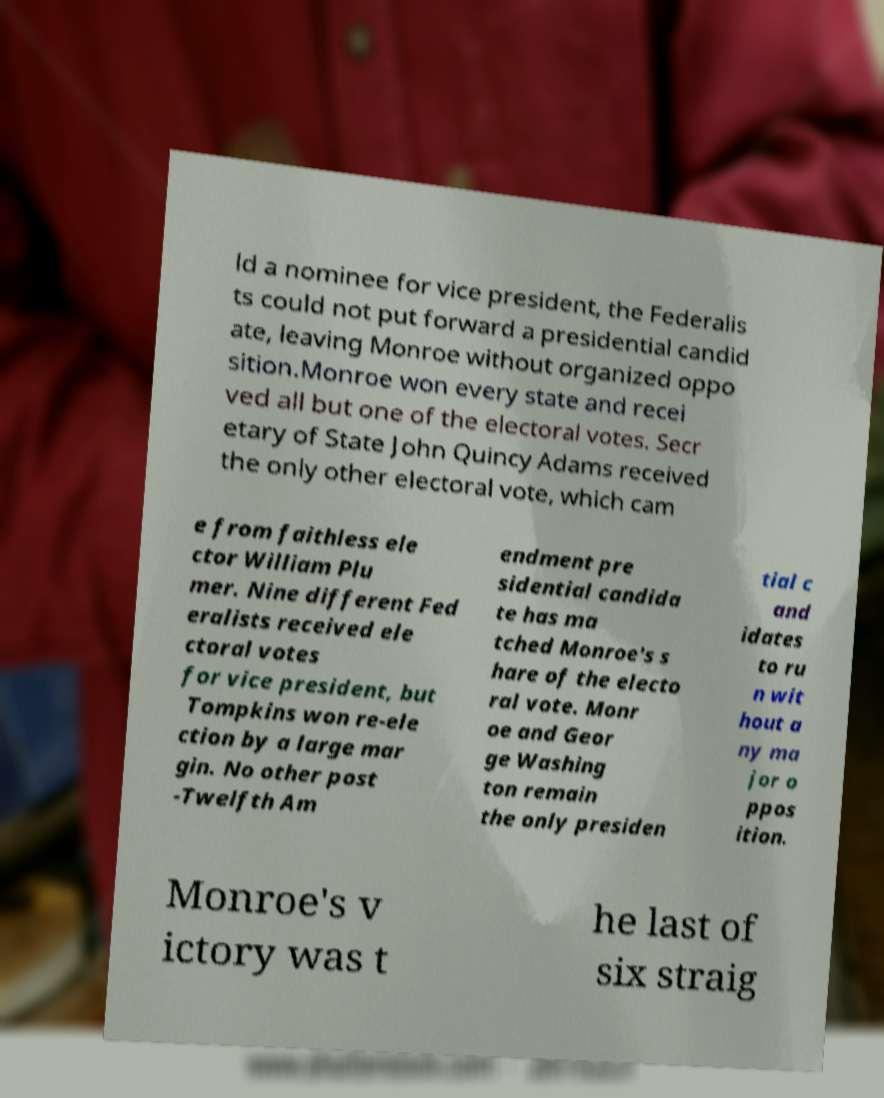Could you extract and type out the text from this image? ld a nominee for vice president, the Federalis ts could not put forward a presidential candid ate, leaving Monroe without organized oppo sition.Monroe won every state and recei ved all but one of the electoral votes. Secr etary of State John Quincy Adams received the only other electoral vote, which cam e from faithless ele ctor William Plu mer. Nine different Fed eralists received ele ctoral votes for vice president, but Tompkins won re-ele ction by a large mar gin. No other post -Twelfth Am endment pre sidential candida te has ma tched Monroe's s hare of the electo ral vote. Monr oe and Geor ge Washing ton remain the only presiden tial c and idates to ru n wit hout a ny ma jor o ppos ition. Monroe's v ictory was t he last of six straig 